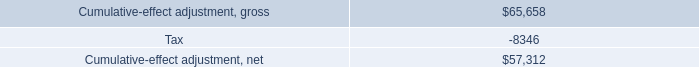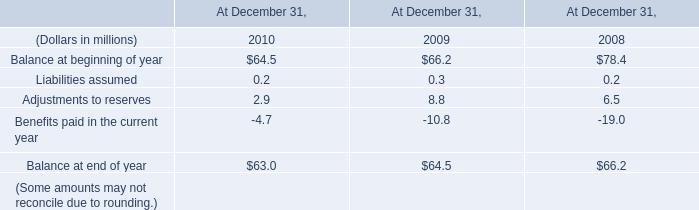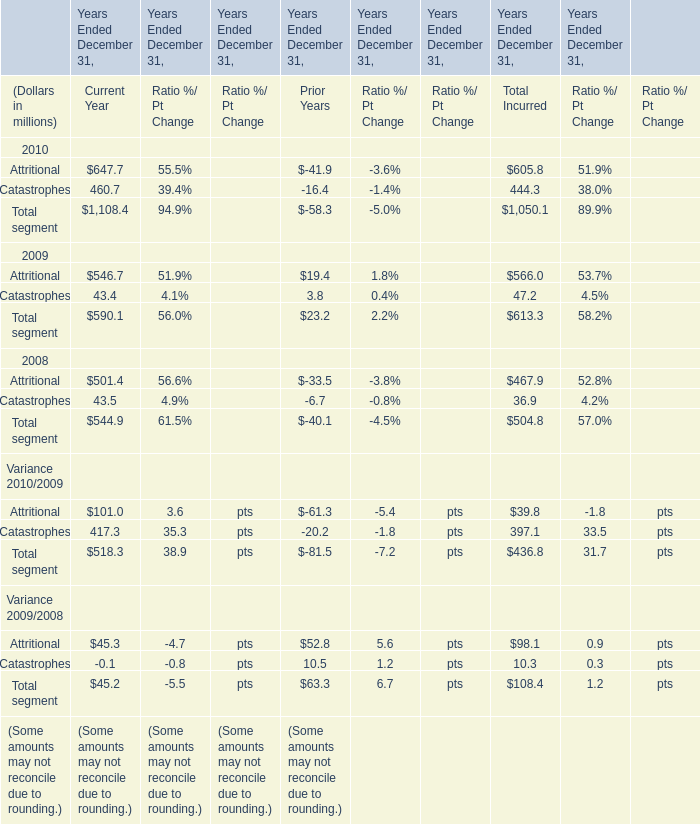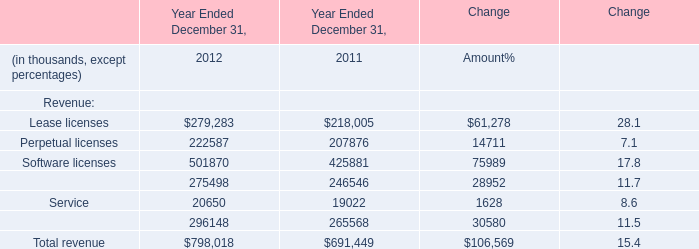When doesAttritional for total incurred reach the largest value? 
Answer: 2010. 